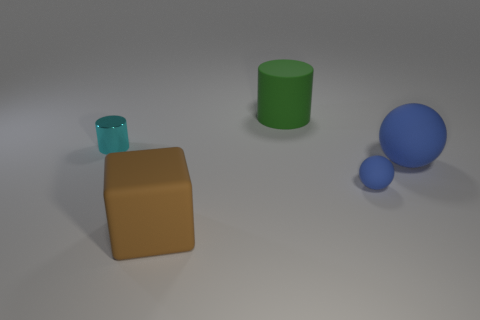How many matte objects are green objects or blue objects? 3 